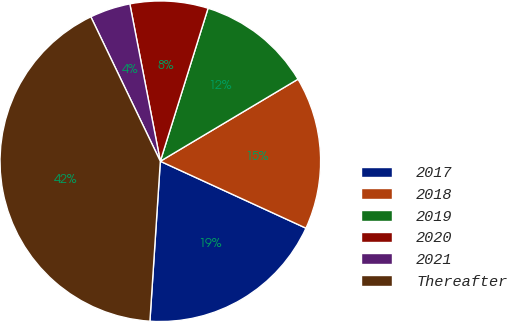Convert chart to OTSL. <chart><loc_0><loc_0><loc_500><loc_500><pie_chart><fcel>2017<fcel>2018<fcel>2019<fcel>2020<fcel>2021<fcel>Thereafter<nl><fcel>19.18%<fcel>15.41%<fcel>11.63%<fcel>7.86%<fcel>4.09%<fcel>41.83%<nl></chart> 